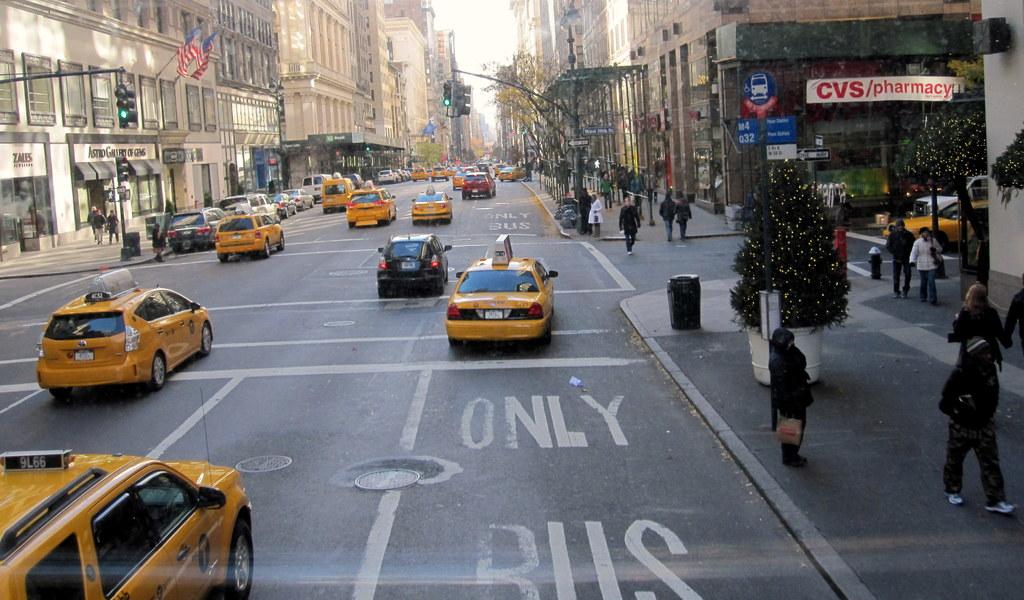Which lane is this?
Offer a terse response. Only bus. What is the name of the pharmacy?
Your answer should be compact. Cvs. 